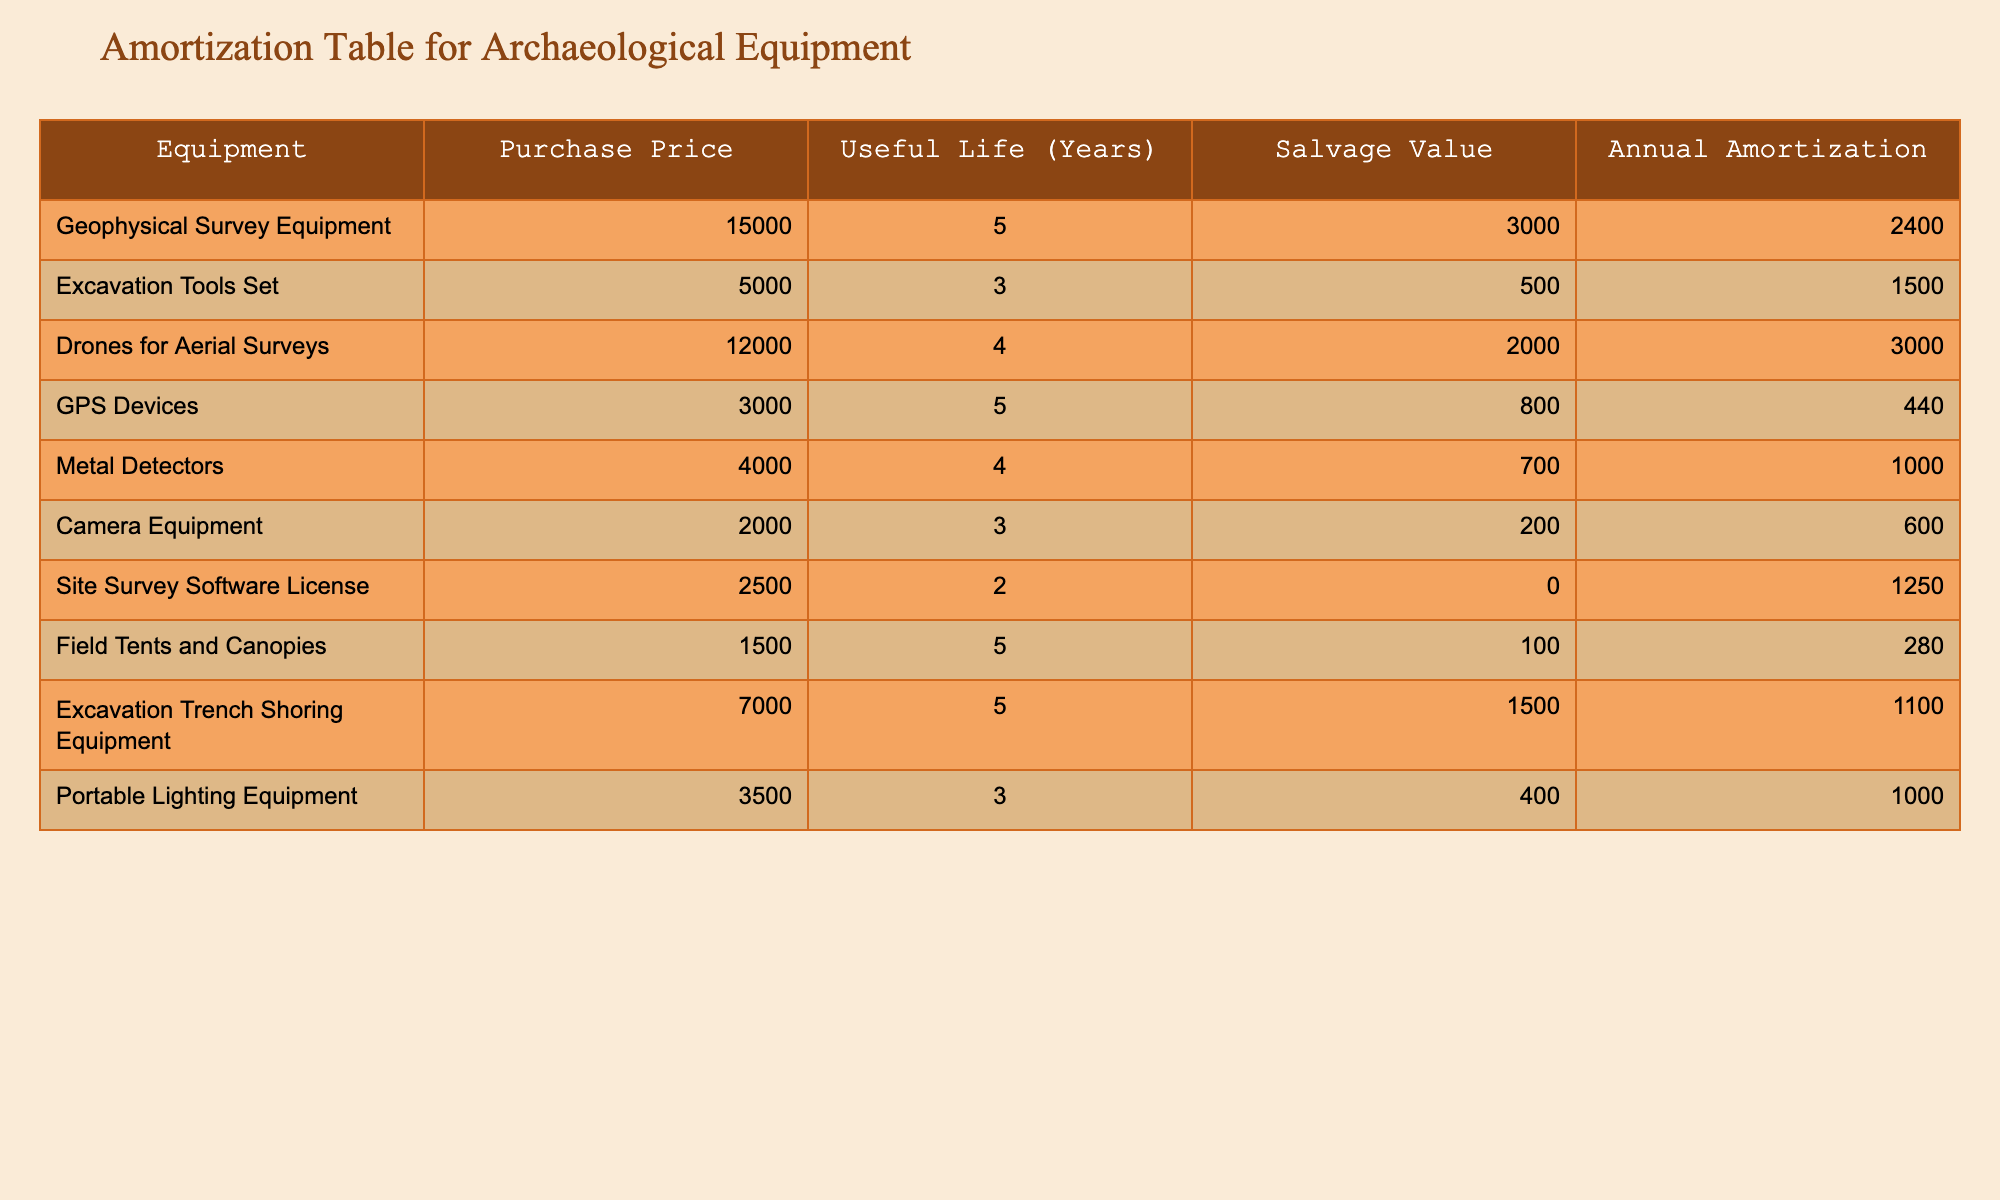What is the purchase price of the Drones for Aerial Surveys? The purchase price is listed directly in the table under the "Purchase Price" column for Drones for Aerial Surveys. The amount given is 12000.
Answer: 12000 What is the annual amortization for the Excavation Tools Set? This value can be found directly in the "Annual Amortization" column corresponding to the Excavation Tools Set, which is 1500.
Answer: 1500 Is the salvage value of the Portable Lighting Equipment greater than that of the Camera Equipment? The salvage value for Portable Lighting Equipment is 400, and for Camera Equipment, it is 200. Since 400 is greater than 200, the answer is yes.
Answer: Yes What is the total annual amortization for all equipment listed? We need to sum the "Annual Amortization" values of all equipment. The total is (2400 + 1500 + 3000 + 440 + 1000 + 600 + 1250 + 280 + 1100 + 1000) = 10570.
Answer: 10570 Which equipment has the longest useful life, and how many years is it? We review the "Useful Life" column for all equipment listings and determine that the Geophysical Survey Equipment, Excavation Trench Shoring Equipment, and Field Tents and Canopies each have a useful life of 5 years, which is the longest.
Answer: Geophysical Survey Equipment, 5 years What is the average salvage value of the equipment used in archaeological surveys? To find the average salvage value, we first sum the "Salvage Value" column, which is (3000 + 500 + 2000 + 800 + 700 + 200 + 0 + 100 + 1500 + 400) = 8800. There are 10 items, so the average is 8800 / 10 = 880.
Answer: 880 Does the Camera Equipment have both a shorter useful life and lower purchase price compared to the Excavation Tools Set? Camera Equipment has a useful life of 3 years (shorter) and a purchase price of 2000 (lower), while Excavation Tools Set has a useful life of 3 years and a purchase price of 5000. Both comparisons are true.
Answer: Yes What is the difference in annual amortization between the Drones for Aerial Surveys and the Geophysical Survey Equipment? The annual amortization for Drones for Aerial Surveys is 3000, and for Geophysical Survey Equipment, it is 2400. The difference is 3000 - 2400 = 600.
Answer: 600 